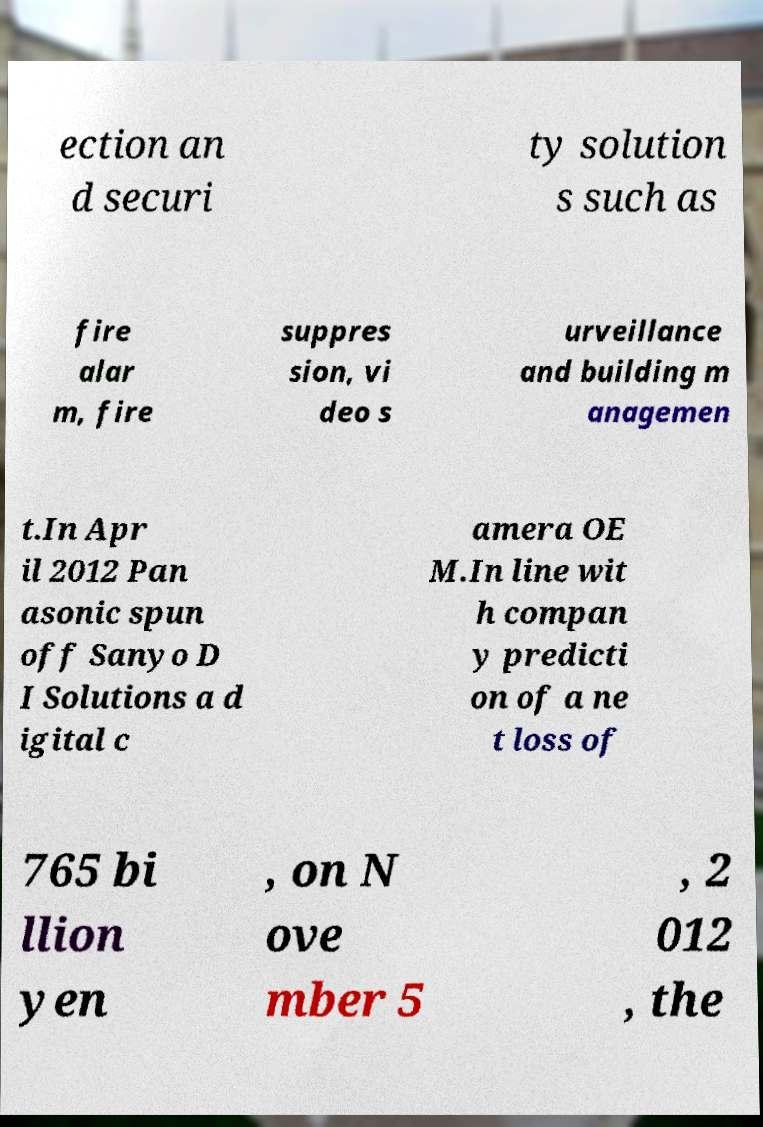Please identify and transcribe the text found in this image. ection an d securi ty solution s such as fire alar m, fire suppres sion, vi deo s urveillance and building m anagemen t.In Apr il 2012 Pan asonic spun off Sanyo D I Solutions a d igital c amera OE M.In line wit h compan y predicti on of a ne t loss of 765 bi llion yen , on N ove mber 5 , 2 012 , the 